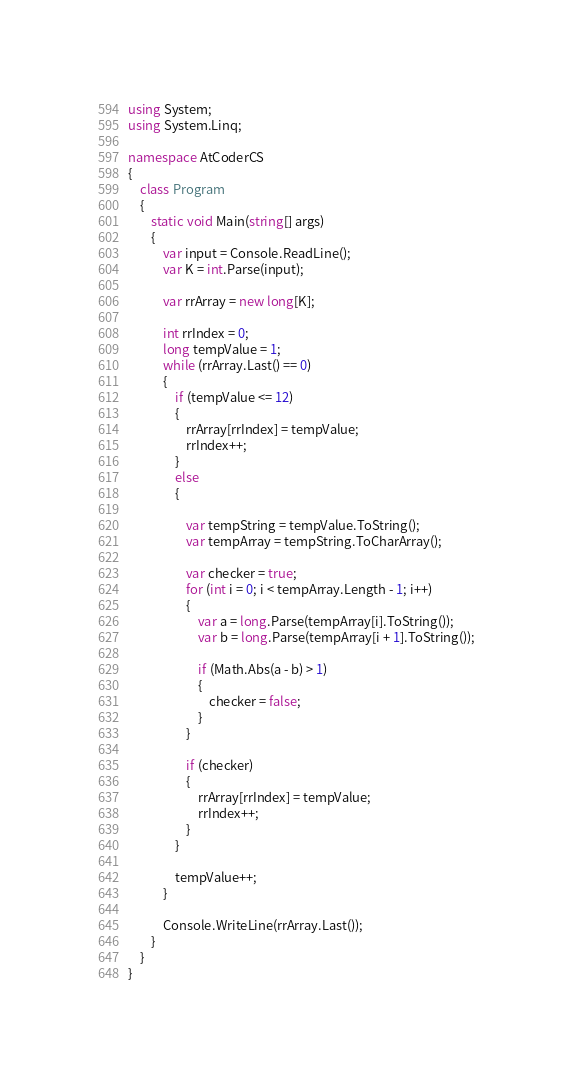<code> <loc_0><loc_0><loc_500><loc_500><_C#_>using System;
using System.Linq;

namespace AtCoderCS
{
    class Program
    {
        static void Main(string[] args)
        {
            var input = Console.ReadLine();
            var K = int.Parse(input);

            var rrArray = new long[K];

            int rrIndex = 0;
            long tempValue = 1;
            while (rrArray.Last() == 0)
            {
                if (tempValue <= 12)
                {
                    rrArray[rrIndex] = tempValue;
                    rrIndex++;
                }
                else
                {

                    var tempString = tempValue.ToString();
                    var tempArray = tempString.ToCharArray();

                    var checker = true;
                    for (int i = 0; i < tempArray.Length - 1; i++)
                    {
                        var a = long.Parse(tempArray[i].ToString());
                        var b = long.Parse(tempArray[i + 1].ToString());

                        if (Math.Abs(a - b) > 1)
                        {
                            checker = false;
                        }
                    }

                    if (checker)
                    {
                        rrArray[rrIndex] = tempValue;
                        rrIndex++;
                    }
                }

                tempValue++;
            }

            Console.WriteLine(rrArray.Last());
        }
    }
}
</code> 